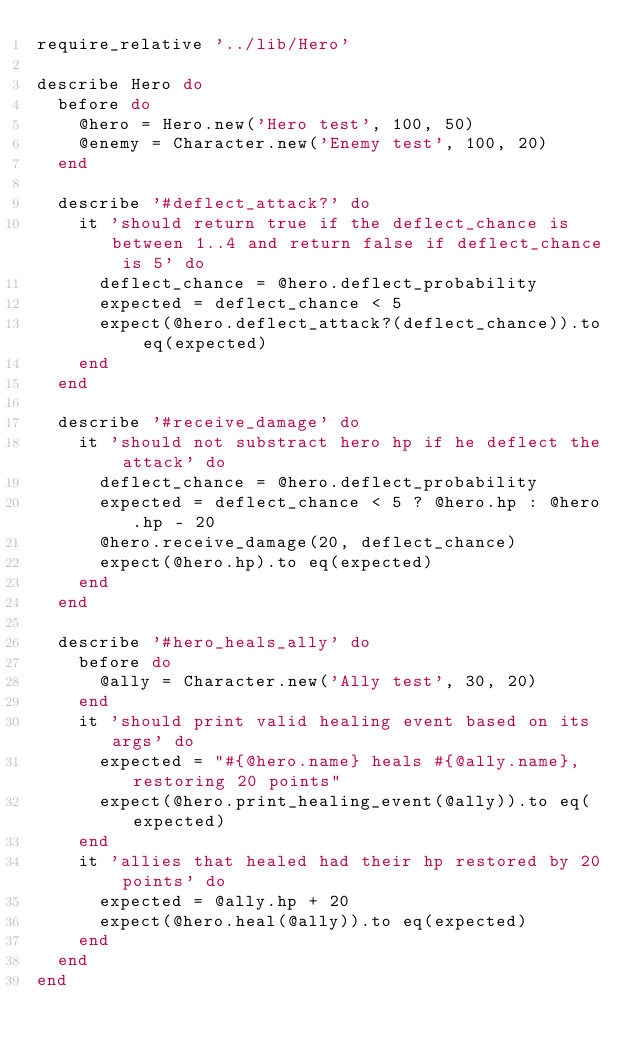<code> <loc_0><loc_0><loc_500><loc_500><_Ruby_>require_relative '../lib/Hero'

describe Hero do
  before do
    @hero = Hero.new('Hero test', 100, 50)
    @enemy = Character.new('Enemy test', 100, 20)
  end

  describe '#deflect_attack?' do
    it 'should return true if the deflect_chance is between 1..4 and return false if deflect_chance is 5' do
      deflect_chance = @hero.deflect_probability
      expected = deflect_chance < 5
      expect(@hero.deflect_attack?(deflect_chance)).to eq(expected)
    end
  end

  describe '#receive_damage' do
    it 'should not substract hero hp if he deflect the attack' do
      deflect_chance = @hero.deflect_probability
      expected = deflect_chance < 5 ? @hero.hp : @hero.hp - 20
      @hero.receive_damage(20, deflect_chance)
      expect(@hero.hp).to eq(expected)
    end
  end

  describe '#hero_heals_ally' do
    before do
      @ally = Character.new('Ally test', 30, 20)
    end
    it 'should print valid healing event based on its args' do
      expected = "#{@hero.name} heals #{@ally.name}, restoring 20 points"
      expect(@hero.print_healing_event(@ally)).to eq(expected)
    end
    it 'allies that healed had their hp restored by 20 points' do
      expected = @ally.hp + 20
      expect(@hero.heal(@ally)).to eq(expected)
    end
  end
end
</code> 